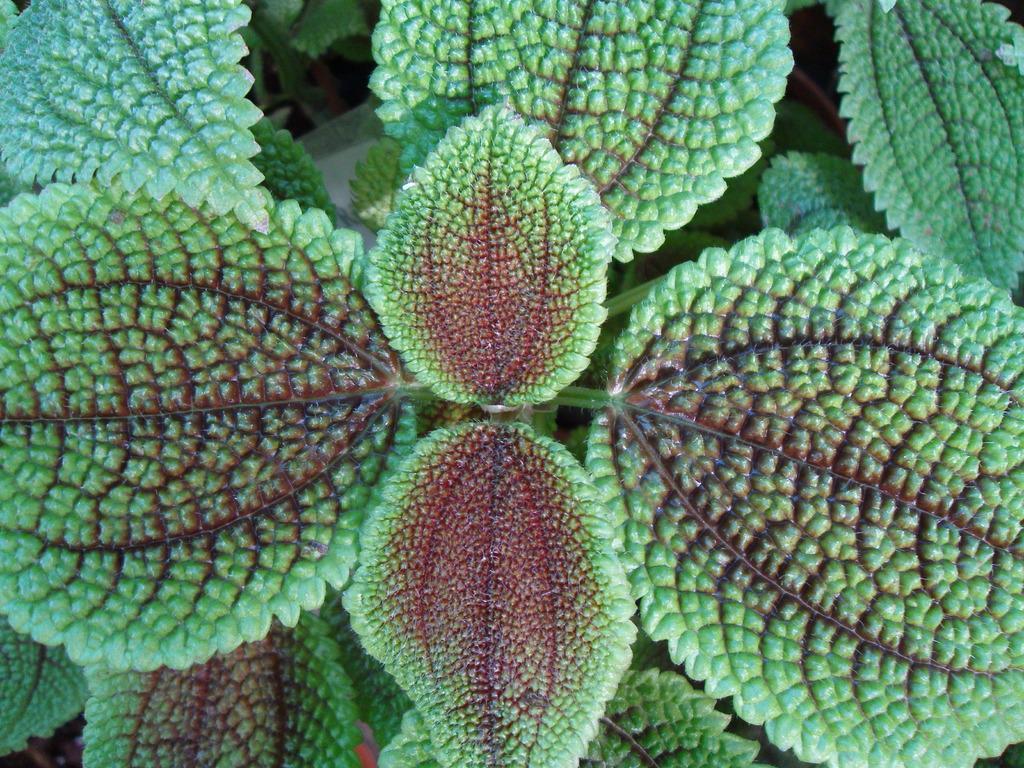Could you give a brief overview of what you see in this image? In the middle of this image, there is a plant having green color leaves. In the background, there are green color leaves. 